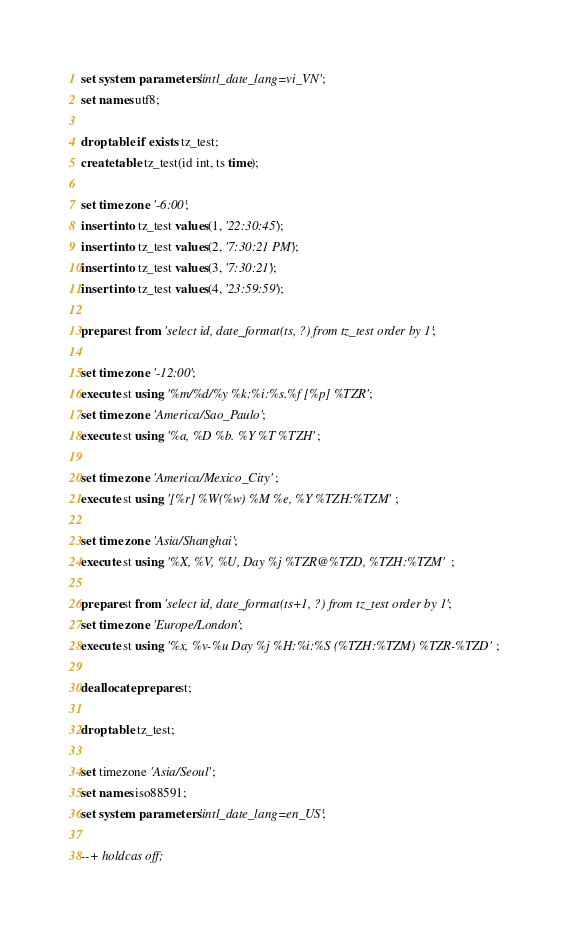Convert code to text. <code><loc_0><loc_0><loc_500><loc_500><_SQL_>

set system parameters 'intl_date_lang=vi_VN';
set names utf8;

drop table if exists tz_test;
create table tz_test(id int, ts time);

set time zone '-6:00';
insert into tz_test values(1, '22:30:45');
insert into tz_test values(2, '7:30:21 PM');
insert into tz_test values(3, '7:30:21');
insert into tz_test values(4, '23:59:59');

prepare st from 'select id, date_format(ts, ?) from tz_test order by 1';

set time zone '-12:00';
execute st using '%m/%d/%y %k:%i:%s.%f [%p] %TZR';
set time zone 'America/Sao_Paulo';
execute st using '%a, %D %b. %Y %T %TZH';

set time zone 'America/Mexico_City';
execute st using '[%r] %W(%w) %M %e, %Y %TZH:%TZM';

set time zone 'Asia/Shanghai';
execute st using '%X, %V, %U, Day %j %TZR@%TZD, %TZH:%TZM';

prepare st from 'select id, date_format(ts+1, ?) from tz_test order by 1';
set time zone 'Europe/London';
execute st using '%x, %v-%u Day %j %H:%i:%S (%TZH:%TZM) %TZR-%TZD';

deallocate prepare st;

drop table tz_test;

set timezone 'Asia/Seoul';
set names iso88591;
set system parameters 'intl_date_lang=en_US';

--+ holdcas off;
</code> 